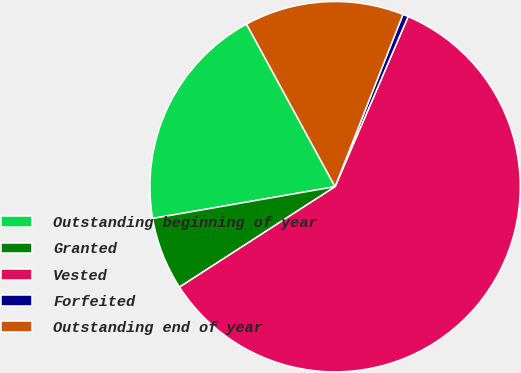Convert chart. <chart><loc_0><loc_0><loc_500><loc_500><pie_chart><fcel>Outstanding beginning of year<fcel>Granted<fcel>Vested<fcel>Forfeited<fcel>Outstanding end of year<nl><fcel>19.81%<fcel>6.38%<fcel>59.42%<fcel>0.48%<fcel>13.91%<nl></chart> 